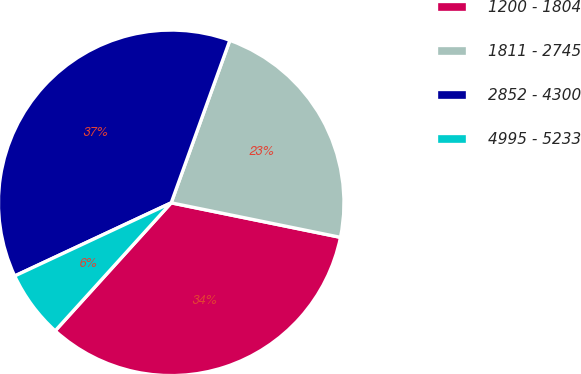Convert chart. <chart><loc_0><loc_0><loc_500><loc_500><pie_chart><fcel>1200 - 1804<fcel>1811 - 2745<fcel>2852 - 4300<fcel>4995 - 5233<nl><fcel>33.52%<fcel>22.69%<fcel>37.47%<fcel>6.32%<nl></chart> 